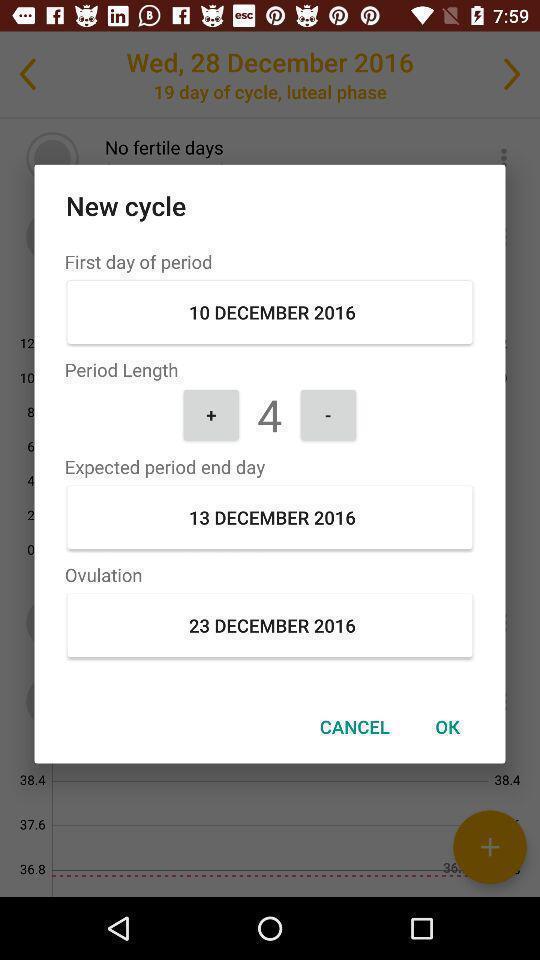Explain the elements present in this screenshot. Pop-up of a period tracking app. 